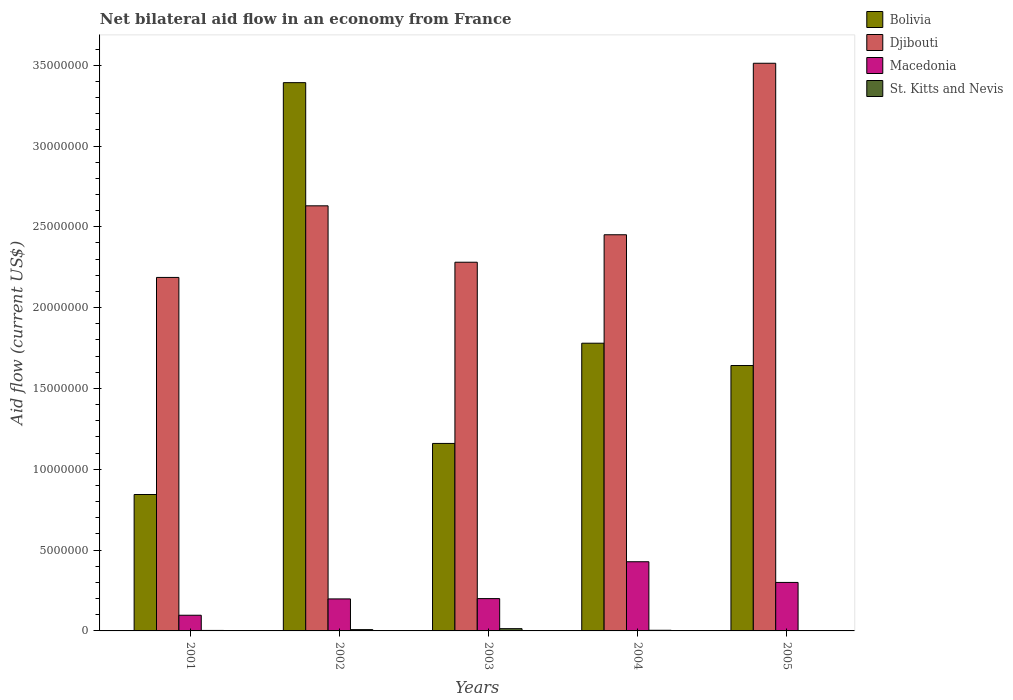How many different coloured bars are there?
Your response must be concise. 4. Are the number of bars per tick equal to the number of legend labels?
Give a very brief answer. No. Are the number of bars on each tick of the X-axis equal?
Your answer should be compact. No. What is the label of the 1st group of bars from the left?
Keep it short and to the point. 2001. What is the net bilateral aid flow in Djibouti in 2003?
Keep it short and to the point. 2.28e+07. Across all years, what is the maximum net bilateral aid flow in Macedonia?
Provide a short and direct response. 4.28e+06. What is the total net bilateral aid flow in St. Kitts and Nevis in the graph?
Provide a succinct answer. 2.90e+05. What is the difference between the net bilateral aid flow in Macedonia in 2001 and that in 2005?
Keep it short and to the point. -2.03e+06. What is the difference between the net bilateral aid flow in Macedonia in 2005 and the net bilateral aid flow in Bolivia in 2004?
Ensure brevity in your answer.  -1.48e+07. What is the average net bilateral aid flow in Bolivia per year?
Your answer should be compact. 1.76e+07. In the year 2003, what is the difference between the net bilateral aid flow in St. Kitts and Nevis and net bilateral aid flow in Macedonia?
Your answer should be compact. -1.86e+06. In how many years, is the net bilateral aid flow in Bolivia greater than 7000000 US$?
Provide a succinct answer. 5. What is the ratio of the net bilateral aid flow in St. Kitts and Nevis in 2001 to that in 2004?
Provide a short and direct response. 0.75. What is the difference between the highest and the second highest net bilateral aid flow in Macedonia?
Your response must be concise. 1.28e+06. What is the difference between the highest and the lowest net bilateral aid flow in Djibouti?
Your response must be concise. 1.32e+07. In how many years, is the net bilateral aid flow in Djibouti greater than the average net bilateral aid flow in Djibouti taken over all years?
Provide a succinct answer. 2. Is the sum of the net bilateral aid flow in St. Kitts and Nevis in 2002 and 2004 greater than the maximum net bilateral aid flow in Bolivia across all years?
Your answer should be very brief. No. How many bars are there?
Your response must be concise. 19. How many years are there in the graph?
Make the answer very short. 5. Are the values on the major ticks of Y-axis written in scientific E-notation?
Your answer should be very brief. No. Does the graph contain any zero values?
Your answer should be compact. Yes. Does the graph contain grids?
Offer a terse response. No. How many legend labels are there?
Make the answer very short. 4. What is the title of the graph?
Provide a succinct answer. Net bilateral aid flow in an economy from France. What is the label or title of the X-axis?
Provide a succinct answer. Years. What is the label or title of the Y-axis?
Give a very brief answer. Aid flow (current US$). What is the Aid flow (current US$) of Bolivia in 2001?
Your answer should be compact. 8.44e+06. What is the Aid flow (current US$) in Djibouti in 2001?
Provide a succinct answer. 2.19e+07. What is the Aid flow (current US$) of Macedonia in 2001?
Your answer should be compact. 9.70e+05. What is the Aid flow (current US$) in Bolivia in 2002?
Your response must be concise. 3.39e+07. What is the Aid flow (current US$) in Djibouti in 2002?
Your answer should be compact. 2.63e+07. What is the Aid flow (current US$) in Macedonia in 2002?
Ensure brevity in your answer.  1.98e+06. What is the Aid flow (current US$) of Bolivia in 2003?
Give a very brief answer. 1.16e+07. What is the Aid flow (current US$) in Djibouti in 2003?
Give a very brief answer. 2.28e+07. What is the Aid flow (current US$) in St. Kitts and Nevis in 2003?
Your response must be concise. 1.40e+05. What is the Aid flow (current US$) of Bolivia in 2004?
Make the answer very short. 1.78e+07. What is the Aid flow (current US$) of Djibouti in 2004?
Provide a succinct answer. 2.45e+07. What is the Aid flow (current US$) of Macedonia in 2004?
Provide a succinct answer. 4.28e+06. What is the Aid flow (current US$) of St. Kitts and Nevis in 2004?
Provide a short and direct response. 4.00e+04. What is the Aid flow (current US$) in Bolivia in 2005?
Your answer should be very brief. 1.64e+07. What is the Aid flow (current US$) of Djibouti in 2005?
Offer a very short reply. 3.51e+07. What is the Aid flow (current US$) of St. Kitts and Nevis in 2005?
Your answer should be compact. 0. Across all years, what is the maximum Aid flow (current US$) in Bolivia?
Offer a terse response. 3.39e+07. Across all years, what is the maximum Aid flow (current US$) in Djibouti?
Your response must be concise. 3.51e+07. Across all years, what is the maximum Aid flow (current US$) of Macedonia?
Ensure brevity in your answer.  4.28e+06. Across all years, what is the maximum Aid flow (current US$) of St. Kitts and Nevis?
Your response must be concise. 1.40e+05. Across all years, what is the minimum Aid flow (current US$) in Bolivia?
Provide a succinct answer. 8.44e+06. Across all years, what is the minimum Aid flow (current US$) in Djibouti?
Your answer should be very brief. 2.19e+07. Across all years, what is the minimum Aid flow (current US$) of Macedonia?
Offer a very short reply. 9.70e+05. What is the total Aid flow (current US$) in Bolivia in the graph?
Provide a succinct answer. 8.82e+07. What is the total Aid flow (current US$) in Djibouti in the graph?
Keep it short and to the point. 1.31e+08. What is the total Aid flow (current US$) in Macedonia in the graph?
Your answer should be compact. 1.22e+07. What is the difference between the Aid flow (current US$) of Bolivia in 2001 and that in 2002?
Your response must be concise. -2.55e+07. What is the difference between the Aid flow (current US$) of Djibouti in 2001 and that in 2002?
Keep it short and to the point. -4.43e+06. What is the difference between the Aid flow (current US$) of Macedonia in 2001 and that in 2002?
Make the answer very short. -1.01e+06. What is the difference between the Aid flow (current US$) of Bolivia in 2001 and that in 2003?
Make the answer very short. -3.16e+06. What is the difference between the Aid flow (current US$) of Djibouti in 2001 and that in 2003?
Ensure brevity in your answer.  -9.40e+05. What is the difference between the Aid flow (current US$) in Macedonia in 2001 and that in 2003?
Provide a succinct answer. -1.03e+06. What is the difference between the Aid flow (current US$) in St. Kitts and Nevis in 2001 and that in 2003?
Your answer should be compact. -1.10e+05. What is the difference between the Aid flow (current US$) in Bolivia in 2001 and that in 2004?
Ensure brevity in your answer.  -9.36e+06. What is the difference between the Aid flow (current US$) of Djibouti in 2001 and that in 2004?
Offer a terse response. -2.64e+06. What is the difference between the Aid flow (current US$) in Macedonia in 2001 and that in 2004?
Provide a succinct answer. -3.31e+06. What is the difference between the Aid flow (current US$) of Bolivia in 2001 and that in 2005?
Your answer should be very brief. -7.98e+06. What is the difference between the Aid flow (current US$) in Djibouti in 2001 and that in 2005?
Provide a short and direct response. -1.32e+07. What is the difference between the Aid flow (current US$) in Macedonia in 2001 and that in 2005?
Give a very brief answer. -2.03e+06. What is the difference between the Aid flow (current US$) in Bolivia in 2002 and that in 2003?
Your answer should be very brief. 2.23e+07. What is the difference between the Aid flow (current US$) in Djibouti in 2002 and that in 2003?
Keep it short and to the point. 3.49e+06. What is the difference between the Aid flow (current US$) in Bolivia in 2002 and that in 2004?
Your answer should be very brief. 1.61e+07. What is the difference between the Aid flow (current US$) of Djibouti in 2002 and that in 2004?
Keep it short and to the point. 1.79e+06. What is the difference between the Aid flow (current US$) in Macedonia in 2002 and that in 2004?
Keep it short and to the point. -2.30e+06. What is the difference between the Aid flow (current US$) of Bolivia in 2002 and that in 2005?
Your answer should be very brief. 1.75e+07. What is the difference between the Aid flow (current US$) of Djibouti in 2002 and that in 2005?
Your answer should be very brief. -8.82e+06. What is the difference between the Aid flow (current US$) of Macedonia in 2002 and that in 2005?
Keep it short and to the point. -1.02e+06. What is the difference between the Aid flow (current US$) in Bolivia in 2003 and that in 2004?
Offer a very short reply. -6.20e+06. What is the difference between the Aid flow (current US$) in Djibouti in 2003 and that in 2004?
Ensure brevity in your answer.  -1.70e+06. What is the difference between the Aid flow (current US$) of Macedonia in 2003 and that in 2004?
Your answer should be compact. -2.28e+06. What is the difference between the Aid flow (current US$) in St. Kitts and Nevis in 2003 and that in 2004?
Provide a succinct answer. 1.00e+05. What is the difference between the Aid flow (current US$) in Bolivia in 2003 and that in 2005?
Offer a terse response. -4.82e+06. What is the difference between the Aid flow (current US$) in Djibouti in 2003 and that in 2005?
Offer a very short reply. -1.23e+07. What is the difference between the Aid flow (current US$) in Bolivia in 2004 and that in 2005?
Your response must be concise. 1.38e+06. What is the difference between the Aid flow (current US$) of Djibouti in 2004 and that in 2005?
Provide a short and direct response. -1.06e+07. What is the difference between the Aid flow (current US$) of Macedonia in 2004 and that in 2005?
Your answer should be compact. 1.28e+06. What is the difference between the Aid flow (current US$) in Bolivia in 2001 and the Aid flow (current US$) in Djibouti in 2002?
Ensure brevity in your answer.  -1.79e+07. What is the difference between the Aid flow (current US$) of Bolivia in 2001 and the Aid flow (current US$) of Macedonia in 2002?
Your answer should be compact. 6.46e+06. What is the difference between the Aid flow (current US$) in Bolivia in 2001 and the Aid flow (current US$) in St. Kitts and Nevis in 2002?
Your answer should be compact. 8.36e+06. What is the difference between the Aid flow (current US$) in Djibouti in 2001 and the Aid flow (current US$) in Macedonia in 2002?
Provide a succinct answer. 1.99e+07. What is the difference between the Aid flow (current US$) in Djibouti in 2001 and the Aid flow (current US$) in St. Kitts and Nevis in 2002?
Ensure brevity in your answer.  2.18e+07. What is the difference between the Aid flow (current US$) of Macedonia in 2001 and the Aid flow (current US$) of St. Kitts and Nevis in 2002?
Offer a terse response. 8.90e+05. What is the difference between the Aid flow (current US$) of Bolivia in 2001 and the Aid flow (current US$) of Djibouti in 2003?
Your response must be concise. -1.44e+07. What is the difference between the Aid flow (current US$) of Bolivia in 2001 and the Aid flow (current US$) of Macedonia in 2003?
Ensure brevity in your answer.  6.44e+06. What is the difference between the Aid flow (current US$) of Bolivia in 2001 and the Aid flow (current US$) of St. Kitts and Nevis in 2003?
Provide a short and direct response. 8.30e+06. What is the difference between the Aid flow (current US$) of Djibouti in 2001 and the Aid flow (current US$) of Macedonia in 2003?
Ensure brevity in your answer.  1.99e+07. What is the difference between the Aid flow (current US$) in Djibouti in 2001 and the Aid flow (current US$) in St. Kitts and Nevis in 2003?
Provide a short and direct response. 2.17e+07. What is the difference between the Aid flow (current US$) in Macedonia in 2001 and the Aid flow (current US$) in St. Kitts and Nevis in 2003?
Make the answer very short. 8.30e+05. What is the difference between the Aid flow (current US$) of Bolivia in 2001 and the Aid flow (current US$) of Djibouti in 2004?
Give a very brief answer. -1.61e+07. What is the difference between the Aid flow (current US$) of Bolivia in 2001 and the Aid flow (current US$) of Macedonia in 2004?
Offer a very short reply. 4.16e+06. What is the difference between the Aid flow (current US$) of Bolivia in 2001 and the Aid flow (current US$) of St. Kitts and Nevis in 2004?
Offer a very short reply. 8.40e+06. What is the difference between the Aid flow (current US$) of Djibouti in 2001 and the Aid flow (current US$) of Macedonia in 2004?
Your response must be concise. 1.76e+07. What is the difference between the Aid flow (current US$) of Djibouti in 2001 and the Aid flow (current US$) of St. Kitts and Nevis in 2004?
Your response must be concise. 2.18e+07. What is the difference between the Aid flow (current US$) of Macedonia in 2001 and the Aid flow (current US$) of St. Kitts and Nevis in 2004?
Keep it short and to the point. 9.30e+05. What is the difference between the Aid flow (current US$) of Bolivia in 2001 and the Aid flow (current US$) of Djibouti in 2005?
Your answer should be very brief. -2.67e+07. What is the difference between the Aid flow (current US$) in Bolivia in 2001 and the Aid flow (current US$) in Macedonia in 2005?
Keep it short and to the point. 5.44e+06. What is the difference between the Aid flow (current US$) in Djibouti in 2001 and the Aid flow (current US$) in Macedonia in 2005?
Offer a very short reply. 1.89e+07. What is the difference between the Aid flow (current US$) of Bolivia in 2002 and the Aid flow (current US$) of Djibouti in 2003?
Your response must be concise. 1.11e+07. What is the difference between the Aid flow (current US$) in Bolivia in 2002 and the Aid flow (current US$) in Macedonia in 2003?
Your answer should be very brief. 3.19e+07. What is the difference between the Aid flow (current US$) in Bolivia in 2002 and the Aid flow (current US$) in St. Kitts and Nevis in 2003?
Make the answer very short. 3.38e+07. What is the difference between the Aid flow (current US$) in Djibouti in 2002 and the Aid flow (current US$) in Macedonia in 2003?
Your answer should be compact. 2.43e+07. What is the difference between the Aid flow (current US$) in Djibouti in 2002 and the Aid flow (current US$) in St. Kitts and Nevis in 2003?
Ensure brevity in your answer.  2.62e+07. What is the difference between the Aid flow (current US$) in Macedonia in 2002 and the Aid flow (current US$) in St. Kitts and Nevis in 2003?
Your response must be concise. 1.84e+06. What is the difference between the Aid flow (current US$) of Bolivia in 2002 and the Aid flow (current US$) of Djibouti in 2004?
Offer a terse response. 9.41e+06. What is the difference between the Aid flow (current US$) of Bolivia in 2002 and the Aid flow (current US$) of Macedonia in 2004?
Ensure brevity in your answer.  2.96e+07. What is the difference between the Aid flow (current US$) of Bolivia in 2002 and the Aid flow (current US$) of St. Kitts and Nevis in 2004?
Provide a short and direct response. 3.39e+07. What is the difference between the Aid flow (current US$) in Djibouti in 2002 and the Aid flow (current US$) in Macedonia in 2004?
Give a very brief answer. 2.20e+07. What is the difference between the Aid flow (current US$) of Djibouti in 2002 and the Aid flow (current US$) of St. Kitts and Nevis in 2004?
Your answer should be very brief. 2.63e+07. What is the difference between the Aid flow (current US$) in Macedonia in 2002 and the Aid flow (current US$) in St. Kitts and Nevis in 2004?
Make the answer very short. 1.94e+06. What is the difference between the Aid flow (current US$) in Bolivia in 2002 and the Aid flow (current US$) in Djibouti in 2005?
Your answer should be compact. -1.20e+06. What is the difference between the Aid flow (current US$) of Bolivia in 2002 and the Aid flow (current US$) of Macedonia in 2005?
Your response must be concise. 3.09e+07. What is the difference between the Aid flow (current US$) in Djibouti in 2002 and the Aid flow (current US$) in Macedonia in 2005?
Provide a short and direct response. 2.33e+07. What is the difference between the Aid flow (current US$) of Bolivia in 2003 and the Aid flow (current US$) of Djibouti in 2004?
Ensure brevity in your answer.  -1.29e+07. What is the difference between the Aid flow (current US$) in Bolivia in 2003 and the Aid flow (current US$) in Macedonia in 2004?
Ensure brevity in your answer.  7.32e+06. What is the difference between the Aid flow (current US$) in Bolivia in 2003 and the Aid flow (current US$) in St. Kitts and Nevis in 2004?
Offer a very short reply. 1.16e+07. What is the difference between the Aid flow (current US$) of Djibouti in 2003 and the Aid flow (current US$) of Macedonia in 2004?
Offer a very short reply. 1.85e+07. What is the difference between the Aid flow (current US$) in Djibouti in 2003 and the Aid flow (current US$) in St. Kitts and Nevis in 2004?
Offer a terse response. 2.28e+07. What is the difference between the Aid flow (current US$) in Macedonia in 2003 and the Aid flow (current US$) in St. Kitts and Nevis in 2004?
Give a very brief answer. 1.96e+06. What is the difference between the Aid flow (current US$) in Bolivia in 2003 and the Aid flow (current US$) in Djibouti in 2005?
Make the answer very short. -2.35e+07. What is the difference between the Aid flow (current US$) of Bolivia in 2003 and the Aid flow (current US$) of Macedonia in 2005?
Provide a succinct answer. 8.60e+06. What is the difference between the Aid flow (current US$) of Djibouti in 2003 and the Aid flow (current US$) of Macedonia in 2005?
Provide a short and direct response. 1.98e+07. What is the difference between the Aid flow (current US$) of Bolivia in 2004 and the Aid flow (current US$) of Djibouti in 2005?
Keep it short and to the point. -1.73e+07. What is the difference between the Aid flow (current US$) in Bolivia in 2004 and the Aid flow (current US$) in Macedonia in 2005?
Ensure brevity in your answer.  1.48e+07. What is the difference between the Aid flow (current US$) in Djibouti in 2004 and the Aid flow (current US$) in Macedonia in 2005?
Keep it short and to the point. 2.15e+07. What is the average Aid flow (current US$) of Bolivia per year?
Offer a very short reply. 1.76e+07. What is the average Aid flow (current US$) in Djibouti per year?
Ensure brevity in your answer.  2.61e+07. What is the average Aid flow (current US$) in Macedonia per year?
Your answer should be compact. 2.45e+06. What is the average Aid flow (current US$) in St. Kitts and Nevis per year?
Offer a terse response. 5.80e+04. In the year 2001, what is the difference between the Aid flow (current US$) in Bolivia and Aid flow (current US$) in Djibouti?
Keep it short and to the point. -1.34e+07. In the year 2001, what is the difference between the Aid flow (current US$) of Bolivia and Aid flow (current US$) of Macedonia?
Keep it short and to the point. 7.47e+06. In the year 2001, what is the difference between the Aid flow (current US$) of Bolivia and Aid flow (current US$) of St. Kitts and Nevis?
Make the answer very short. 8.41e+06. In the year 2001, what is the difference between the Aid flow (current US$) of Djibouti and Aid flow (current US$) of Macedonia?
Give a very brief answer. 2.09e+07. In the year 2001, what is the difference between the Aid flow (current US$) of Djibouti and Aid flow (current US$) of St. Kitts and Nevis?
Make the answer very short. 2.18e+07. In the year 2001, what is the difference between the Aid flow (current US$) of Macedonia and Aid flow (current US$) of St. Kitts and Nevis?
Provide a succinct answer. 9.40e+05. In the year 2002, what is the difference between the Aid flow (current US$) of Bolivia and Aid flow (current US$) of Djibouti?
Offer a terse response. 7.62e+06. In the year 2002, what is the difference between the Aid flow (current US$) in Bolivia and Aid flow (current US$) in Macedonia?
Provide a short and direct response. 3.19e+07. In the year 2002, what is the difference between the Aid flow (current US$) of Bolivia and Aid flow (current US$) of St. Kitts and Nevis?
Ensure brevity in your answer.  3.38e+07. In the year 2002, what is the difference between the Aid flow (current US$) in Djibouti and Aid flow (current US$) in Macedonia?
Offer a terse response. 2.43e+07. In the year 2002, what is the difference between the Aid flow (current US$) of Djibouti and Aid flow (current US$) of St. Kitts and Nevis?
Keep it short and to the point. 2.62e+07. In the year 2002, what is the difference between the Aid flow (current US$) in Macedonia and Aid flow (current US$) in St. Kitts and Nevis?
Provide a short and direct response. 1.90e+06. In the year 2003, what is the difference between the Aid flow (current US$) of Bolivia and Aid flow (current US$) of Djibouti?
Your response must be concise. -1.12e+07. In the year 2003, what is the difference between the Aid flow (current US$) in Bolivia and Aid flow (current US$) in Macedonia?
Your answer should be very brief. 9.60e+06. In the year 2003, what is the difference between the Aid flow (current US$) in Bolivia and Aid flow (current US$) in St. Kitts and Nevis?
Your answer should be very brief. 1.15e+07. In the year 2003, what is the difference between the Aid flow (current US$) of Djibouti and Aid flow (current US$) of Macedonia?
Ensure brevity in your answer.  2.08e+07. In the year 2003, what is the difference between the Aid flow (current US$) of Djibouti and Aid flow (current US$) of St. Kitts and Nevis?
Offer a very short reply. 2.27e+07. In the year 2003, what is the difference between the Aid flow (current US$) of Macedonia and Aid flow (current US$) of St. Kitts and Nevis?
Your answer should be compact. 1.86e+06. In the year 2004, what is the difference between the Aid flow (current US$) in Bolivia and Aid flow (current US$) in Djibouti?
Provide a short and direct response. -6.71e+06. In the year 2004, what is the difference between the Aid flow (current US$) of Bolivia and Aid flow (current US$) of Macedonia?
Your response must be concise. 1.35e+07. In the year 2004, what is the difference between the Aid flow (current US$) in Bolivia and Aid flow (current US$) in St. Kitts and Nevis?
Provide a short and direct response. 1.78e+07. In the year 2004, what is the difference between the Aid flow (current US$) of Djibouti and Aid flow (current US$) of Macedonia?
Keep it short and to the point. 2.02e+07. In the year 2004, what is the difference between the Aid flow (current US$) of Djibouti and Aid flow (current US$) of St. Kitts and Nevis?
Provide a succinct answer. 2.45e+07. In the year 2004, what is the difference between the Aid flow (current US$) in Macedonia and Aid flow (current US$) in St. Kitts and Nevis?
Ensure brevity in your answer.  4.24e+06. In the year 2005, what is the difference between the Aid flow (current US$) in Bolivia and Aid flow (current US$) in Djibouti?
Your answer should be very brief. -1.87e+07. In the year 2005, what is the difference between the Aid flow (current US$) in Bolivia and Aid flow (current US$) in Macedonia?
Ensure brevity in your answer.  1.34e+07. In the year 2005, what is the difference between the Aid flow (current US$) in Djibouti and Aid flow (current US$) in Macedonia?
Your answer should be very brief. 3.21e+07. What is the ratio of the Aid flow (current US$) of Bolivia in 2001 to that in 2002?
Provide a short and direct response. 0.25. What is the ratio of the Aid flow (current US$) in Djibouti in 2001 to that in 2002?
Make the answer very short. 0.83. What is the ratio of the Aid flow (current US$) in Macedonia in 2001 to that in 2002?
Make the answer very short. 0.49. What is the ratio of the Aid flow (current US$) of St. Kitts and Nevis in 2001 to that in 2002?
Give a very brief answer. 0.38. What is the ratio of the Aid flow (current US$) of Bolivia in 2001 to that in 2003?
Provide a succinct answer. 0.73. What is the ratio of the Aid flow (current US$) in Djibouti in 2001 to that in 2003?
Provide a short and direct response. 0.96. What is the ratio of the Aid flow (current US$) of Macedonia in 2001 to that in 2003?
Offer a terse response. 0.48. What is the ratio of the Aid flow (current US$) in St. Kitts and Nevis in 2001 to that in 2003?
Your response must be concise. 0.21. What is the ratio of the Aid flow (current US$) in Bolivia in 2001 to that in 2004?
Offer a terse response. 0.47. What is the ratio of the Aid flow (current US$) in Djibouti in 2001 to that in 2004?
Provide a short and direct response. 0.89. What is the ratio of the Aid flow (current US$) of Macedonia in 2001 to that in 2004?
Your answer should be compact. 0.23. What is the ratio of the Aid flow (current US$) in Bolivia in 2001 to that in 2005?
Provide a short and direct response. 0.51. What is the ratio of the Aid flow (current US$) of Djibouti in 2001 to that in 2005?
Your response must be concise. 0.62. What is the ratio of the Aid flow (current US$) in Macedonia in 2001 to that in 2005?
Keep it short and to the point. 0.32. What is the ratio of the Aid flow (current US$) of Bolivia in 2002 to that in 2003?
Keep it short and to the point. 2.92. What is the ratio of the Aid flow (current US$) of Djibouti in 2002 to that in 2003?
Ensure brevity in your answer.  1.15. What is the ratio of the Aid flow (current US$) of St. Kitts and Nevis in 2002 to that in 2003?
Keep it short and to the point. 0.57. What is the ratio of the Aid flow (current US$) in Bolivia in 2002 to that in 2004?
Keep it short and to the point. 1.91. What is the ratio of the Aid flow (current US$) of Djibouti in 2002 to that in 2004?
Offer a terse response. 1.07. What is the ratio of the Aid flow (current US$) in Macedonia in 2002 to that in 2004?
Keep it short and to the point. 0.46. What is the ratio of the Aid flow (current US$) in St. Kitts and Nevis in 2002 to that in 2004?
Offer a very short reply. 2. What is the ratio of the Aid flow (current US$) of Bolivia in 2002 to that in 2005?
Give a very brief answer. 2.07. What is the ratio of the Aid flow (current US$) of Djibouti in 2002 to that in 2005?
Your response must be concise. 0.75. What is the ratio of the Aid flow (current US$) in Macedonia in 2002 to that in 2005?
Your answer should be compact. 0.66. What is the ratio of the Aid flow (current US$) of Bolivia in 2003 to that in 2004?
Provide a short and direct response. 0.65. What is the ratio of the Aid flow (current US$) in Djibouti in 2003 to that in 2004?
Keep it short and to the point. 0.93. What is the ratio of the Aid flow (current US$) of Macedonia in 2003 to that in 2004?
Your response must be concise. 0.47. What is the ratio of the Aid flow (current US$) in St. Kitts and Nevis in 2003 to that in 2004?
Your answer should be compact. 3.5. What is the ratio of the Aid flow (current US$) in Bolivia in 2003 to that in 2005?
Provide a short and direct response. 0.71. What is the ratio of the Aid flow (current US$) of Djibouti in 2003 to that in 2005?
Provide a short and direct response. 0.65. What is the ratio of the Aid flow (current US$) of Macedonia in 2003 to that in 2005?
Make the answer very short. 0.67. What is the ratio of the Aid flow (current US$) in Bolivia in 2004 to that in 2005?
Provide a short and direct response. 1.08. What is the ratio of the Aid flow (current US$) in Djibouti in 2004 to that in 2005?
Give a very brief answer. 0.7. What is the ratio of the Aid flow (current US$) of Macedonia in 2004 to that in 2005?
Offer a terse response. 1.43. What is the difference between the highest and the second highest Aid flow (current US$) of Bolivia?
Your response must be concise. 1.61e+07. What is the difference between the highest and the second highest Aid flow (current US$) of Djibouti?
Ensure brevity in your answer.  8.82e+06. What is the difference between the highest and the second highest Aid flow (current US$) in Macedonia?
Your answer should be very brief. 1.28e+06. What is the difference between the highest and the second highest Aid flow (current US$) in St. Kitts and Nevis?
Give a very brief answer. 6.00e+04. What is the difference between the highest and the lowest Aid flow (current US$) of Bolivia?
Your answer should be very brief. 2.55e+07. What is the difference between the highest and the lowest Aid flow (current US$) in Djibouti?
Give a very brief answer. 1.32e+07. What is the difference between the highest and the lowest Aid flow (current US$) of Macedonia?
Offer a very short reply. 3.31e+06. 